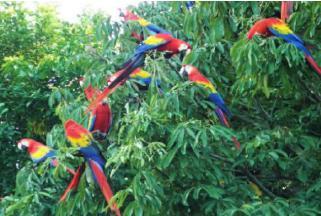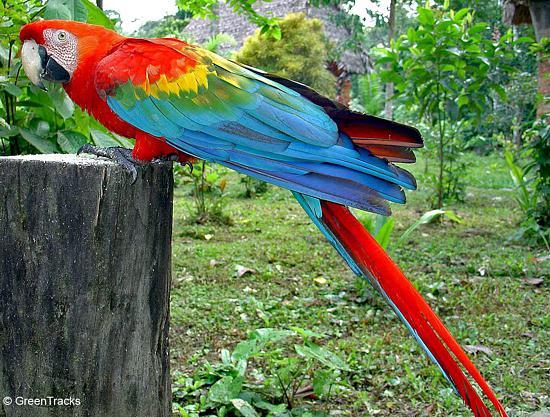The first image is the image on the left, the second image is the image on the right. Given the left and right images, does the statement "There is no more than one parrot in the left image." hold true? Answer yes or no. No. The first image is the image on the left, the second image is the image on the right. Given the left and right images, does the statement "An image shows a single red-headed bird, which is in flight with its body at a diagonal angle." hold true? Answer yes or no. No. 